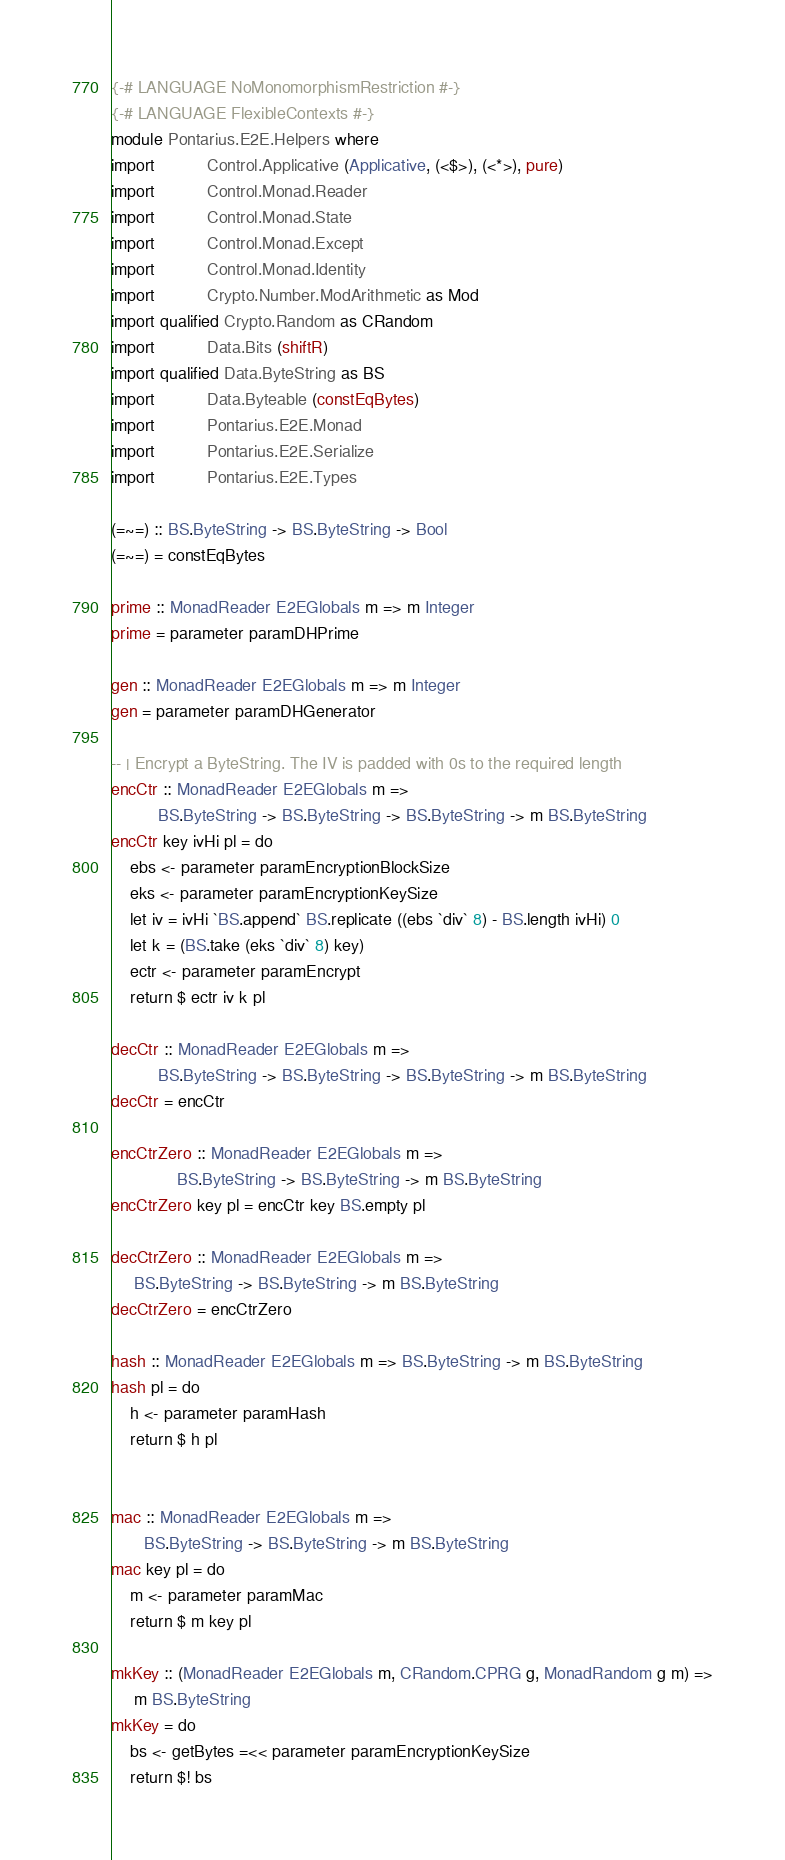<code> <loc_0><loc_0><loc_500><loc_500><_Haskell_>{-# LANGUAGE NoMonomorphismRestriction #-}
{-# LANGUAGE FlexibleContexts #-}
module Pontarius.E2E.Helpers where
import           Control.Applicative (Applicative, (<$>), (<*>), pure)
import           Control.Monad.Reader
import           Control.Monad.State
import           Control.Monad.Except
import           Control.Monad.Identity
import           Crypto.Number.ModArithmetic as Mod
import qualified Crypto.Random as CRandom
import           Data.Bits (shiftR)
import qualified Data.ByteString as BS
import           Data.Byteable (constEqBytes)
import           Pontarius.E2E.Monad
import           Pontarius.E2E.Serialize
import           Pontarius.E2E.Types

(=~=) :: BS.ByteString -> BS.ByteString -> Bool
(=~=) = constEqBytes

prime :: MonadReader E2EGlobals m => m Integer
prime = parameter paramDHPrime

gen :: MonadReader E2EGlobals m => m Integer
gen = parameter paramDHGenerator

-- | Encrypt a ByteString. The IV is padded with 0s to the required length
encCtr :: MonadReader E2EGlobals m =>
          BS.ByteString -> BS.ByteString -> BS.ByteString -> m BS.ByteString
encCtr key ivHi pl = do
    ebs <- parameter paramEncryptionBlockSize
    eks <- parameter paramEncryptionKeySize
    let iv = ivHi `BS.append` BS.replicate ((ebs `div` 8) - BS.length ivHi) 0
    let k = (BS.take (eks `div` 8) key)
    ectr <- parameter paramEncrypt
    return $ ectr iv k pl

decCtr :: MonadReader E2EGlobals m =>
          BS.ByteString -> BS.ByteString -> BS.ByteString -> m BS.ByteString
decCtr = encCtr

encCtrZero :: MonadReader E2EGlobals m =>
              BS.ByteString -> BS.ByteString -> m BS.ByteString
encCtrZero key pl = encCtr key BS.empty pl

decCtrZero :: MonadReader E2EGlobals m =>
     BS.ByteString -> BS.ByteString -> m BS.ByteString
decCtrZero = encCtrZero

hash :: MonadReader E2EGlobals m => BS.ByteString -> m BS.ByteString
hash pl = do
    h <- parameter paramHash
    return $ h pl


mac :: MonadReader E2EGlobals m =>
       BS.ByteString -> BS.ByteString -> m BS.ByteString
mac key pl = do
    m <- parameter paramMac
    return $ m key pl

mkKey :: (MonadReader E2EGlobals m, CRandom.CPRG g, MonadRandom g m) =>
     m BS.ByteString
mkKey = do
    bs <- getBytes =<< parameter paramEncryptionKeySize
    return $! bs
</code> 